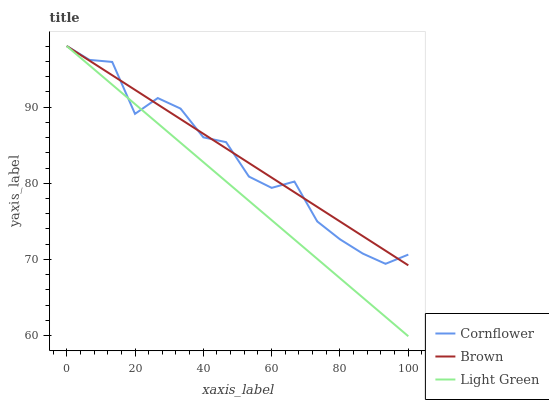Does Light Green have the minimum area under the curve?
Answer yes or no. Yes. Does Brown have the maximum area under the curve?
Answer yes or no. Yes. Does Brown have the minimum area under the curve?
Answer yes or no. No. Does Light Green have the maximum area under the curve?
Answer yes or no. No. Is Brown the smoothest?
Answer yes or no. Yes. Is Cornflower the roughest?
Answer yes or no. Yes. Is Light Green the smoothest?
Answer yes or no. No. Is Light Green the roughest?
Answer yes or no. No. Does Light Green have the lowest value?
Answer yes or no. Yes. Does Brown have the lowest value?
Answer yes or no. No. Does Brown have the highest value?
Answer yes or no. Yes. Does Light Green intersect Cornflower?
Answer yes or no. Yes. Is Light Green less than Cornflower?
Answer yes or no. No. Is Light Green greater than Cornflower?
Answer yes or no. No. 